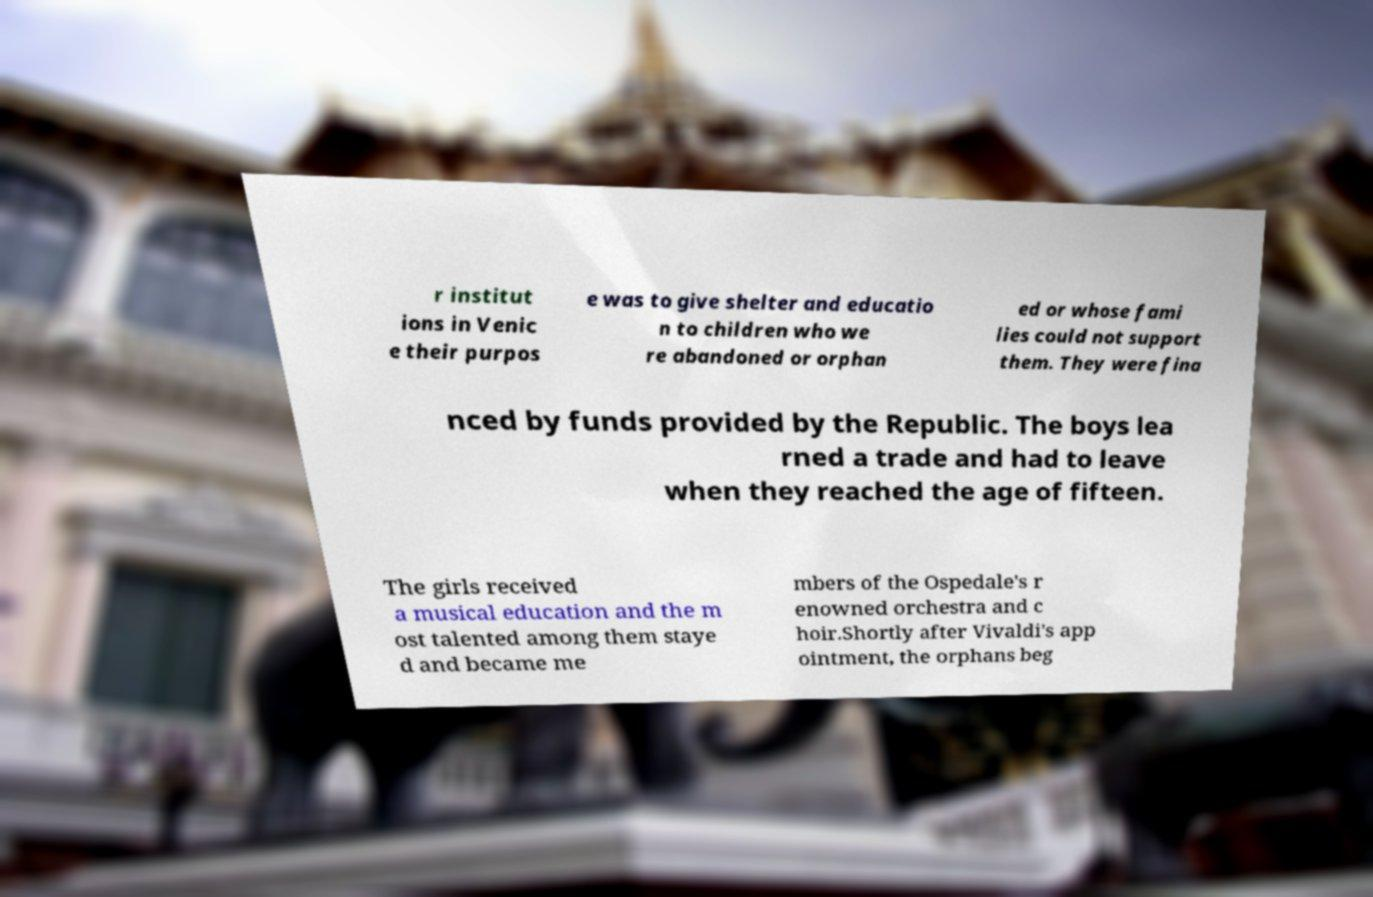Can you accurately transcribe the text from the provided image for me? r institut ions in Venic e their purpos e was to give shelter and educatio n to children who we re abandoned or orphan ed or whose fami lies could not support them. They were fina nced by funds provided by the Republic. The boys lea rned a trade and had to leave when they reached the age of fifteen. The girls received a musical education and the m ost talented among them staye d and became me mbers of the Ospedale's r enowned orchestra and c hoir.Shortly after Vivaldi's app ointment, the orphans beg 